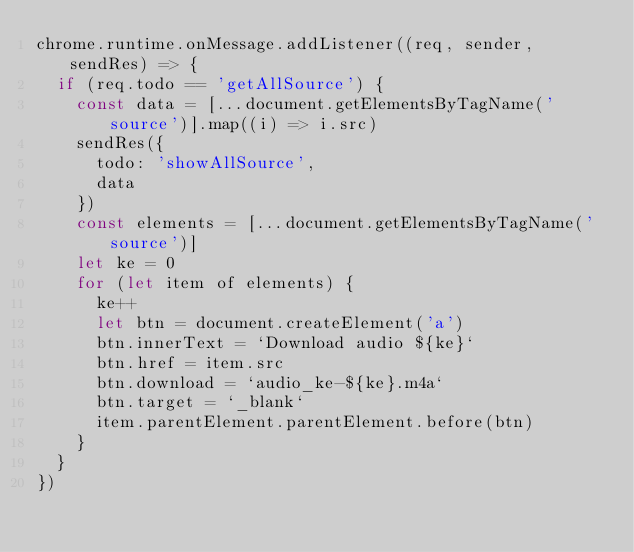Convert code to text. <code><loc_0><loc_0><loc_500><loc_500><_JavaScript_>chrome.runtime.onMessage.addListener((req, sender, sendRes) => {
  if (req.todo == 'getAllSource') {
    const data = [...document.getElementsByTagName('source')].map((i) => i.src)
    sendRes({
      todo: 'showAllSource',
      data
    })
    const elements = [...document.getElementsByTagName('source')]
    let ke = 0
    for (let item of elements) {
      ke++
      let btn = document.createElement('a')
      btn.innerText = `Download audio ${ke}`
      btn.href = item.src
      btn.download = `audio_ke-${ke}.m4a`
      btn.target = `_blank`
      item.parentElement.parentElement.before(btn)
    }
  }
})</code> 